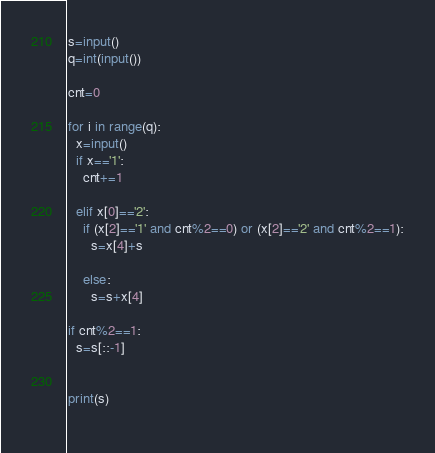<code> <loc_0><loc_0><loc_500><loc_500><_Python_>s=input()
q=int(input())

cnt=0

for i in range(q):
  x=input()
  if x=='1':
    cnt+=1
    
  elif x[0]=='2':
    if (x[2]=='1' and cnt%2==0) or (x[2]=='2' and cnt%2==1):
      s=x[4]+s
      
    else:
      s=s+x[4]
      
if cnt%2==1:
  s=s[::-1]
  

print(s)
    </code> 